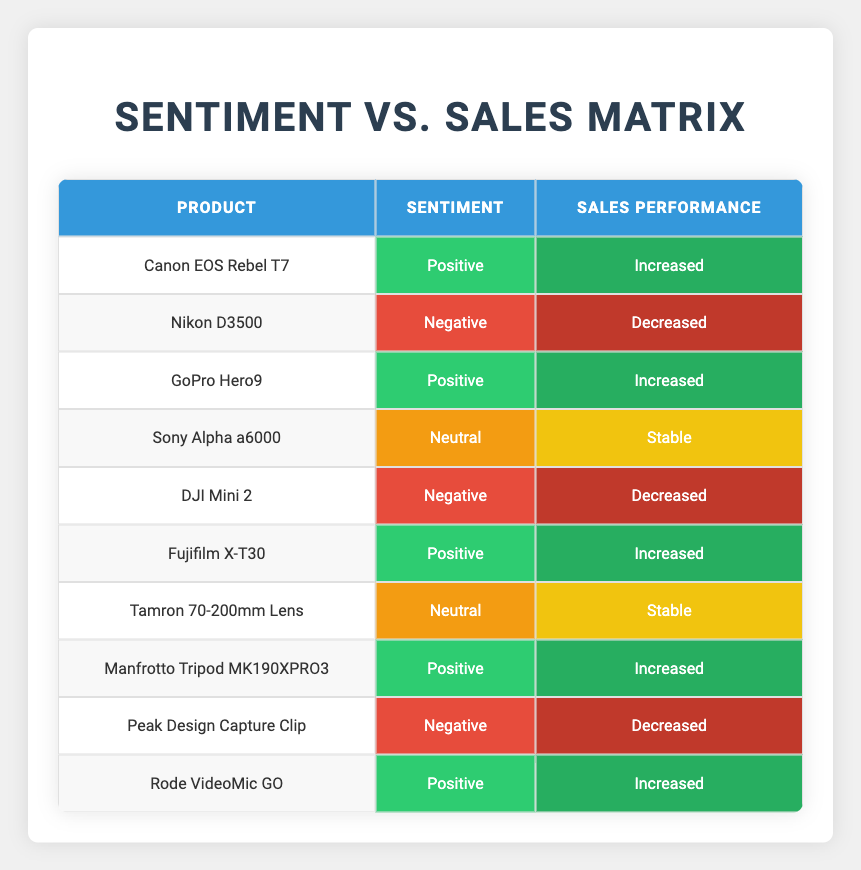What is the sales performance for the Canon EOS Rebel T7? According to the table, the Canon EOS Rebel T7 has an actual sales performance categorized as "Increased" based on its positive sentiment.
Answer: Increased How many products have a Neutral sentiment? There are two products that display a Neutral sentiment: the Sony Alpha a6000 and the Tamron 70-200mm Lens.
Answer: 2 Is it true that all products with Negative sentiment have decreased sales? Yes, both products with a Negative sentiment, the Nikon D3500 and the DJI Mini 2, are reported to have Decreased sales.
Answer: Yes What percentage of products showed Increased sales? Out of 10 products, 6 showed Increased sales. So, (6/10) * 100 = 60%.
Answer: 60% Which product has Stable sales performance, and what is its sentiment? The product with Stable sales performance is the Sony Alpha a6000, and its sentiment is Neutral according to the table.
Answer: Sony Alpha a6000, Neutral What is the average sentiment rating of products that have Increased sales? There are 6 products with Increased sales. Their sentiments are Positive. Average sentiment for positive is counted as 1 sentiment value (counting only Positive reviews), leading to an average sentiment rating of 1.
Answer: Positive How many products have both Positive sentiment and Increased sales? The products with both Positive sentiment and Increased sales are the Canon EOS Rebel T7, GoPro Hero9, Fujifilm X-T30, Manfrotto Tripod MK190XPRO3, and Rode VideoMic GO, making a total of 5 products.
Answer: 5 Which product has the highest combination of Negative sentiment and Decreased sales? The products with Negative sentiment are Nikon D3500, DJI Mini 2, and Peak Design Capture Clip; all have Decreased sales, meaning they equally exhibit this combination.
Answer: None, all equal What can be inferred about the sentiment of products that have Stable sales? The data shows that the only products with Stable sales are Sony Alpha a6000 and Tamron 70-200mm Lens, which have a Neutral sentiment, indicating neutrality correlates with stable performance.
Answer: Neutral sentiment correlates with Stable sales 